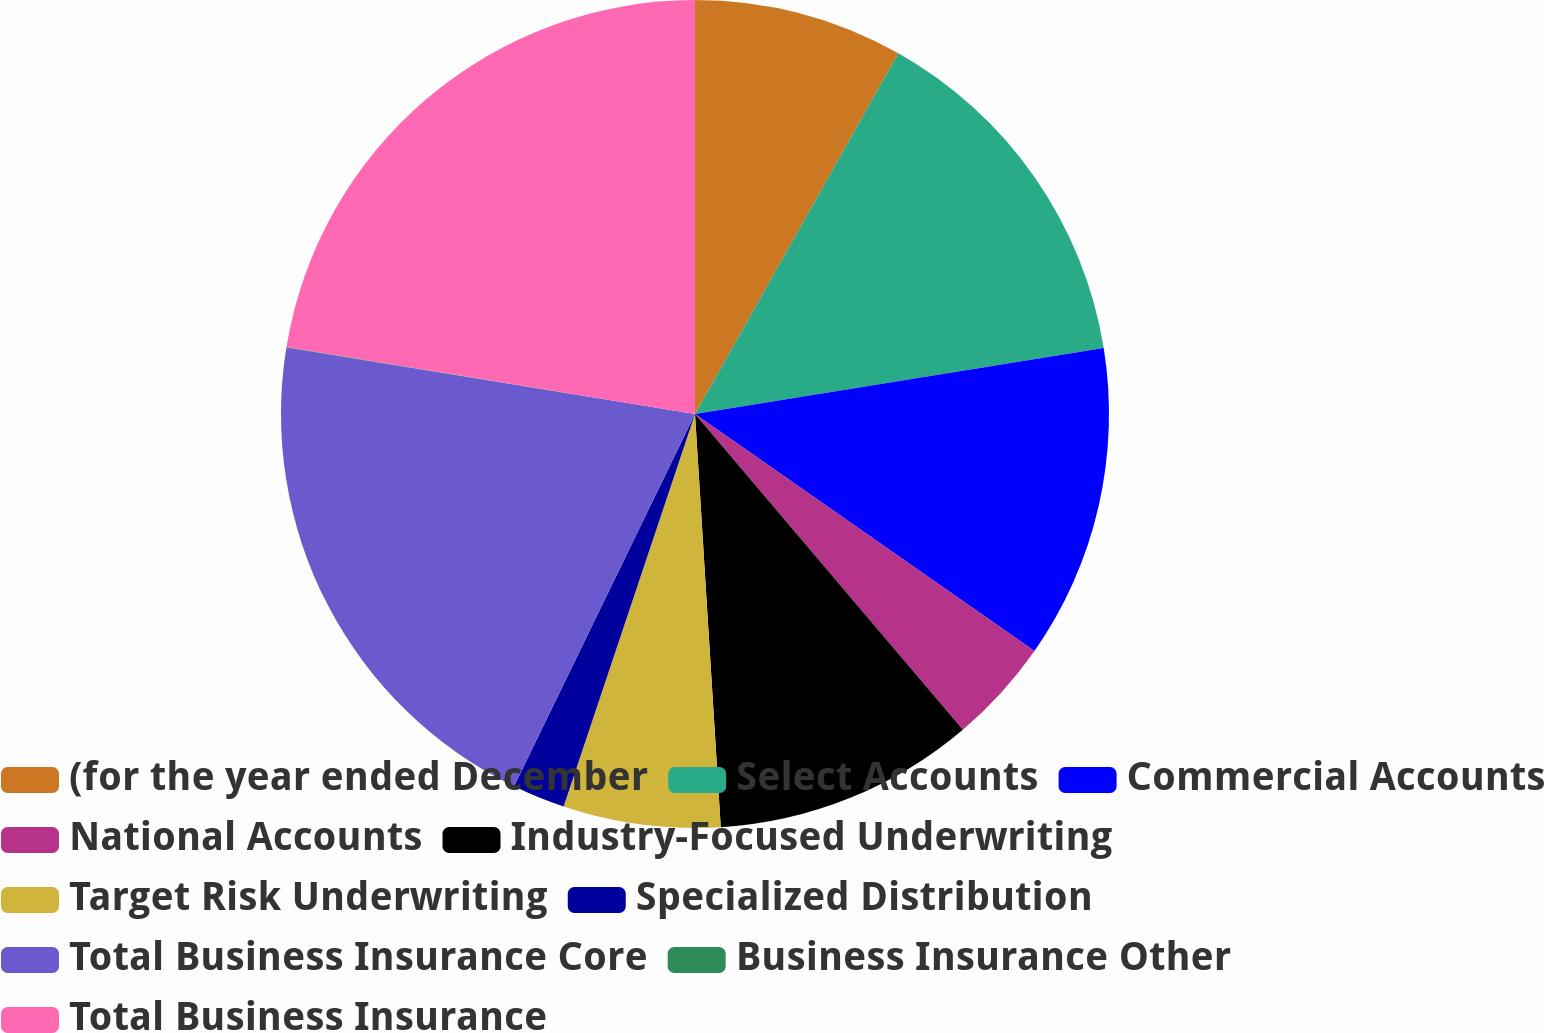Convert chart to OTSL. <chart><loc_0><loc_0><loc_500><loc_500><pie_chart><fcel>(for the year ended December<fcel>Select Accounts<fcel>Commercial Accounts<fcel>National Accounts<fcel>Industry-Focused Underwriting<fcel>Target Risk Underwriting<fcel>Specialized Distribution<fcel>Total Business Insurance Core<fcel>Business Insurance Other<fcel>Total Business Insurance<nl><fcel>8.17%<fcel>14.28%<fcel>12.25%<fcel>4.1%<fcel>10.21%<fcel>6.13%<fcel>2.06%<fcel>20.37%<fcel>0.02%<fcel>22.41%<nl></chart> 